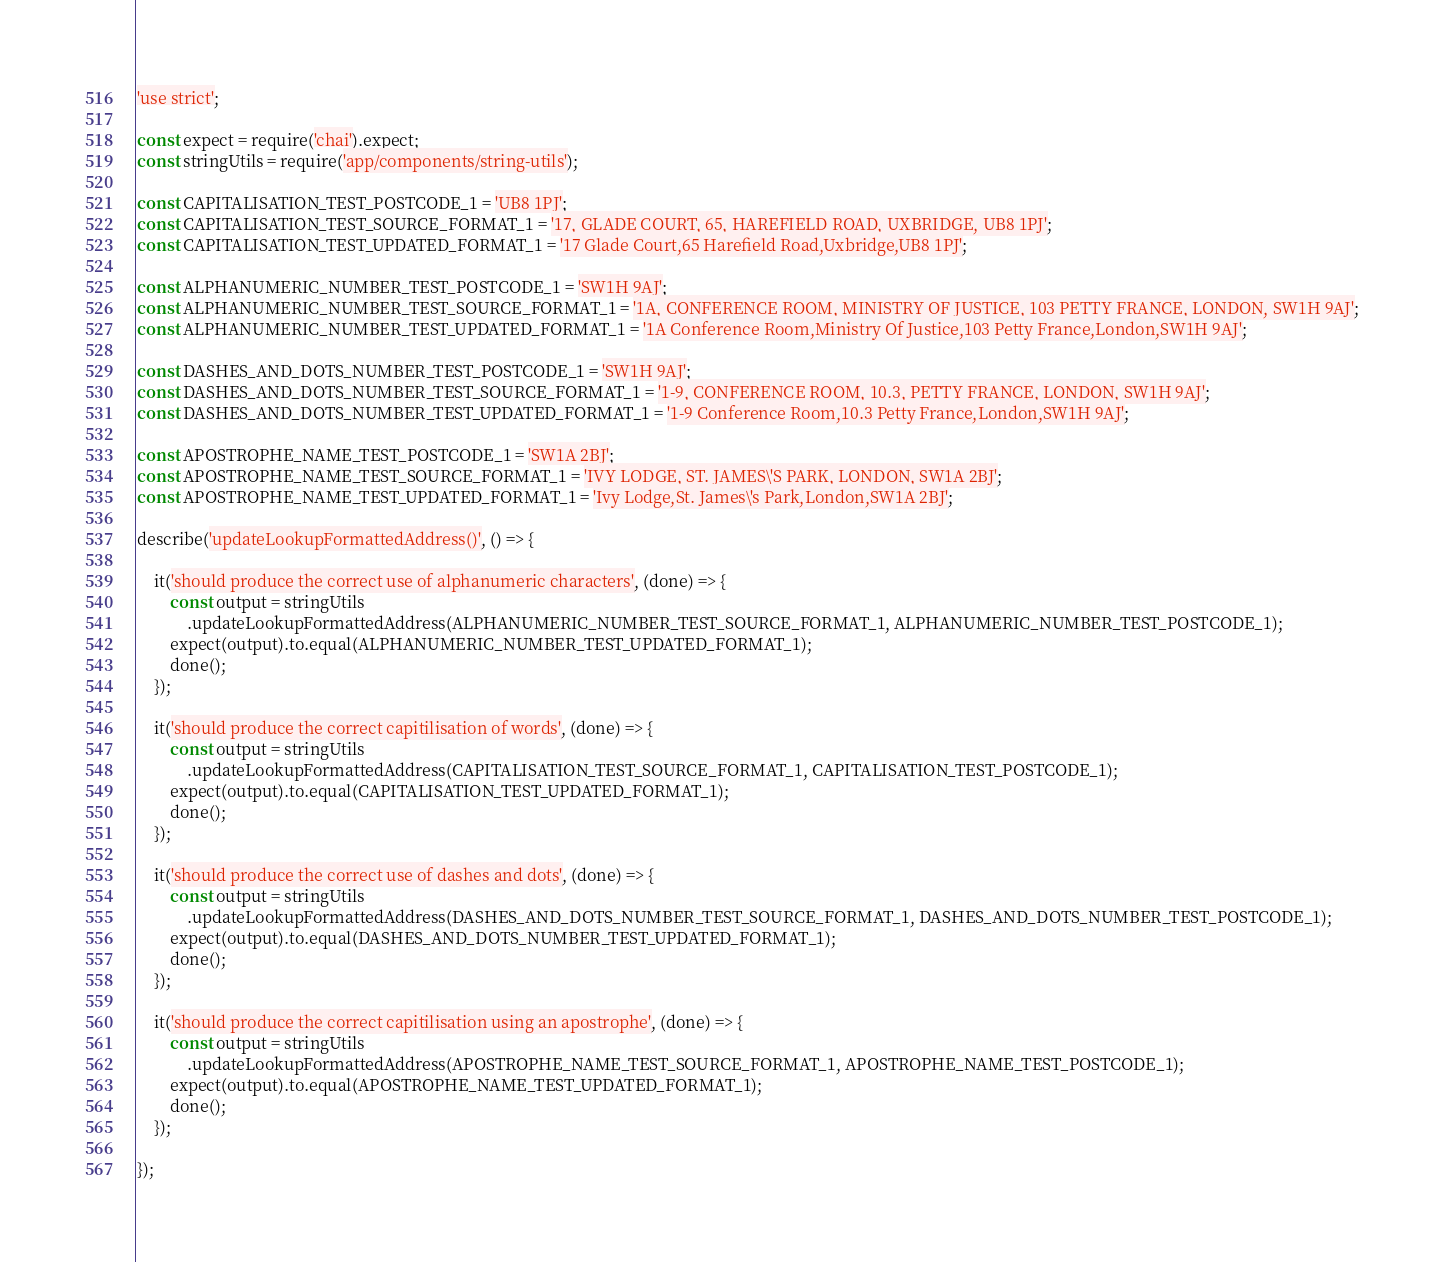<code> <loc_0><loc_0><loc_500><loc_500><_JavaScript_>'use strict';

const expect = require('chai').expect;
const stringUtils = require('app/components/string-utils');

const CAPITALISATION_TEST_POSTCODE_1 = 'UB8 1PJ';
const CAPITALISATION_TEST_SOURCE_FORMAT_1 = '17, GLADE COURT, 65, HAREFIELD ROAD, UXBRIDGE, UB8 1PJ';
const CAPITALISATION_TEST_UPDATED_FORMAT_1 = '17 Glade Court,65 Harefield Road,Uxbridge,UB8 1PJ';

const ALPHANUMERIC_NUMBER_TEST_POSTCODE_1 = 'SW1H 9AJ';
const ALPHANUMERIC_NUMBER_TEST_SOURCE_FORMAT_1 = '1A, CONFERENCE ROOM, MINISTRY OF JUSTICE, 103 PETTY FRANCE, LONDON, SW1H 9AJ';
const ALPHANUMERIC_NUMBER_TEST_UPDATED_FORMAT_1 = '1A Conference Room,Ministry Of Justice,103 Petty France,London,SW1H 9AJ';

const DASHES_AND_DOTS_NUMBER_TEST_POSTCODE_1 = 'SW1H 9AJ';
const DASHES_AND_DOTS_NUMBER_TEST_SOURCE_FORMAT_1 = '1-9, CONFERENCE ROOM, 10.3, PETTY FRANCE, LONDON, SW1H 9AJ';
const DASHES_AND_DOTS_NUMBER_TEST_UPDATED_FORMAT_1 = '1-9 Conference Room,10.3 Petty France,London,SW1H 9AJ';

const APOSTROPHE_NAME_TEST_POSTCODE_1 = 'SW1A 2BJ';
const APOSTROPHE_NAME_TEST_SOURCE_FORMAT_1 = 'IVY LODGE, ST. JAMES\'S PARK, LONDON, SW1A 2BJ';
const APOSTROPHE_NAME_TEST_UPDATED_FORMAT_1 = 'Ivy Lodge,St. James\'s Park,London,SW1A 2BJ';

describe('updateLookupFormattedAddress()', () => {

    it('should produce the correct use of alphanumeric characters', (done) => {
        const output = stringUtils
            .updateLookupFormattedAddress(ALPHANUMERIC_NUMBER_TEST_SOURCE_FORMAT_1, ALPHANUMERIC_NUMBER_TEST_POSTCODE_1);
        expect(output).to.equal(ALPHANUMERIC_NUMBER_TEST_UPDATED_FORMAT_1);
        done();
    });

    it('should produce the correct capitilisation of words', (done) => {
        const output = stringUtils
            .updateLookupFormattedAddress(CAPITALISATION_TEST_SOURCE_FORMAT_1, CAPITALISATION_TEST_POSTCODE_1);
        expect(output).to.equal(CAPITALISATION_TEST_UPDATED_FORMAT_1);
        done();
    });

    it('should produce the correct use of dashes and dots', (done) => {
        const output = stringUtils
            .updateLookupFormattedAddress(DASHES_AND_DOTS_NUMBER_TEST_SOURCE_FORMAT_1, DASHES_AND_DOTS_NUMBER_TEST_POSTCODE_1);
        expect(output).to.equal(DASHES_AND_DOTS_NUMBER_TEST_UPDATED_FORMAT_1);
        done();
    });

    it('should produce the correct capitilisation using an apostrophe', (done) => {
        const output = stringUtils
            .updateLookupFormattedAddress(APOSTROPHE_NAME_TEST_SOURCE_FORMAT_1, APOSTROPHE_NAME_TEST_POSTCODE_1);
        expect(output).to.equal(APOSTROPHE_NAME_TEST_UPDATED_FORMAT_1);
        done();
    });

});
</code> 